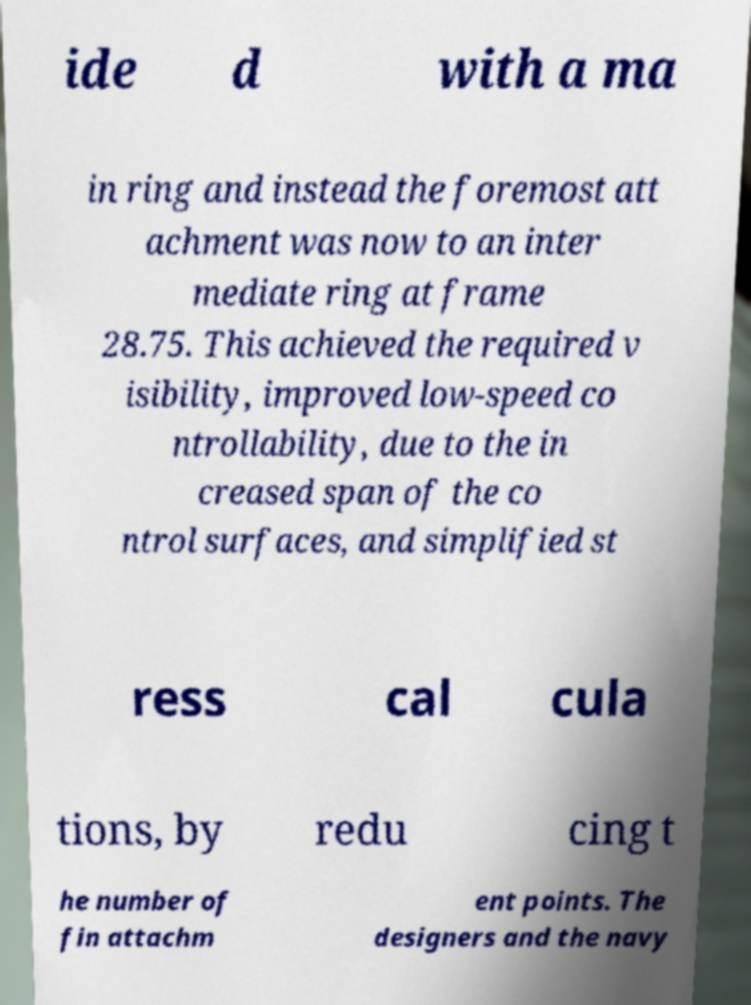Please read and relay the text visible in this image. What does it say? ide d with a ma in ring and instead the foremost att achment was now to an inter mediate ring at frame 28.75. This achieved the required v isibility, improved low-speed co ntrollability, due to the in creased span of the co ntrol surfaces, and simplified st ress cal cula tions, by redu cing t he number of fin attachm ent points. The designers and the navy 